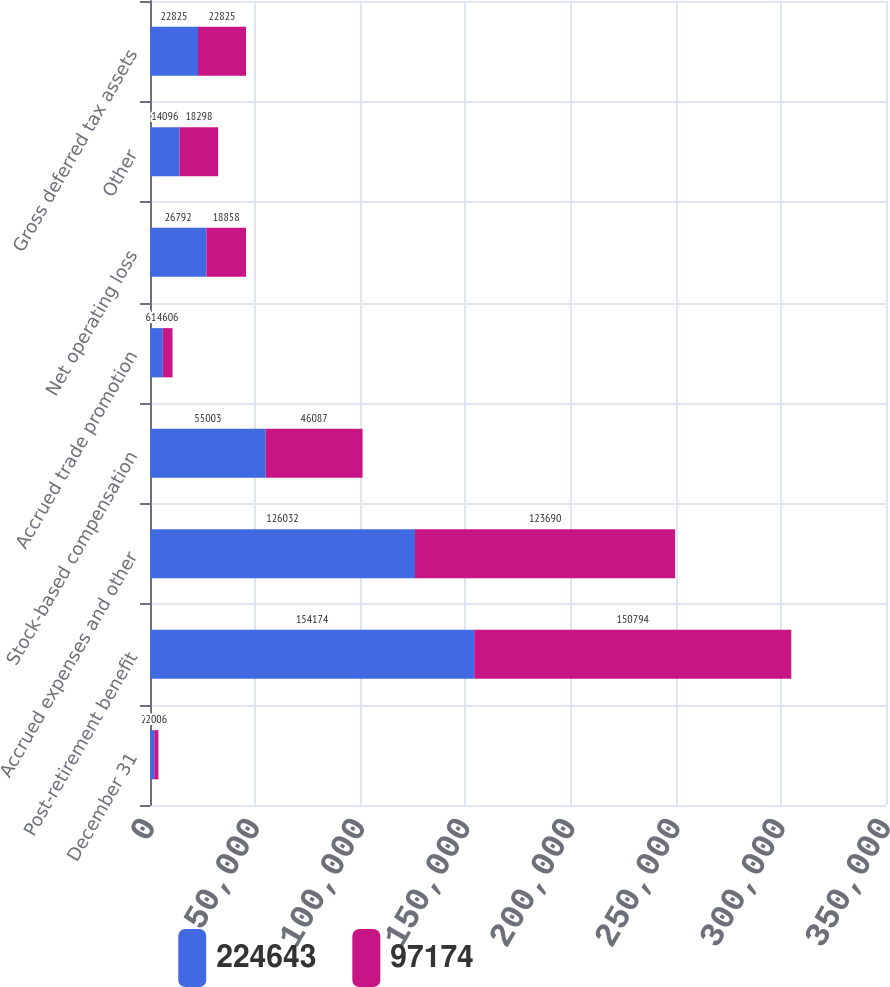Convert chart to OTSL. <chart><loc_0><loc_0><loc_500><loc_500><stacked_bar_chart><ecel><fcel>December 31<fcel>Post-retirement benefit<fcel>Accrued expenses and other<fcel>Stock-based compensation<fcel>Accrued trade promotion<fcel>Net operating loss<fcel>Other<fcel>Gross deferred tax assets<nl><fcel>224643<fcel>2007<fcel>154174<fcel>126032<fcel>55003<fcel>6107<fcel>26792<fcel>14096<fcel>22825<nl><fcel>97174<fcel>2006<fcel>150794<fcel>123690<fcel>46087<fcel>4606<fcel>18858<fcel>18298<fcel>22825<nl></chart> 